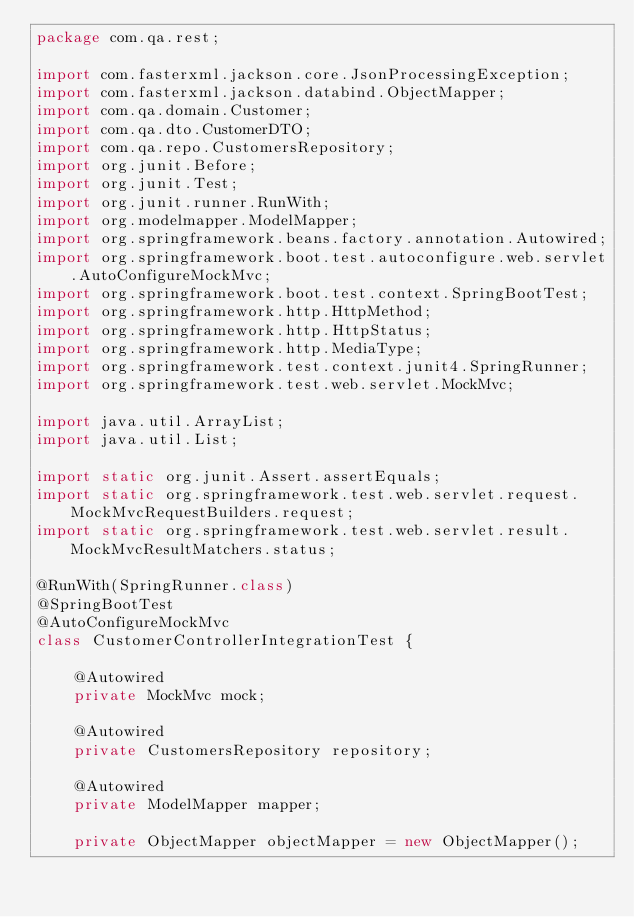<code> <loc_0><loc_0><loc_500><loc_500><_Java_>package com.qa.rest;

import com.fasterxml.jackson.core.JsonProcessingException;
import com.fasterxml.jackson.databind.ObjectMapper;
import com.qa.domain.Customer;
import com.qa.dto.CustomerDTO;
import com.qa.repo.CustomersRepository;
import org.junit.Before;
import org.junit.Test;
import org.junit.runner.RunWith;
import org.modelmapper.ModelMapper;
import org.springframework.beans.factory.annotation.Autowired;
import org.springframework.boot.test.autoconfigure.web.servlet.AutoConfigureMockMvc;
import org.springframework.boot.test.context.SpringBootTest;
import org.springframework.http.HttpMethod;
import org.springframework.http.HttpStatus;
import org.springframework.http.MediaType;
import org.springframework.test.context.junit4.SpringRunner;
import org.springframework.test.web.servlet.MockMvc;

import java.util.ArrayList;
import java.util.List;

import static org.junit.Assert.assertEquals;
import static org.springframework.test.web.servlet.request.MockMvcRequestBuilders.request;
import static org.springframework.test.web.servlet.result.MockMvcResultMatchers.status;

@RunWith(SpringRunner.class)
@SpringBootTest
@AutoConfigureMockMvc
class CustomerControllerIntegrationTest {

    @Autowired
    private MockMvc mock;

    @Autowired
    private CustomersRepository repository;

    @Autowired
    private ModelMapper mapper;

    private ObjectMapper objectMapper = new ObjectMapper();
</code> 